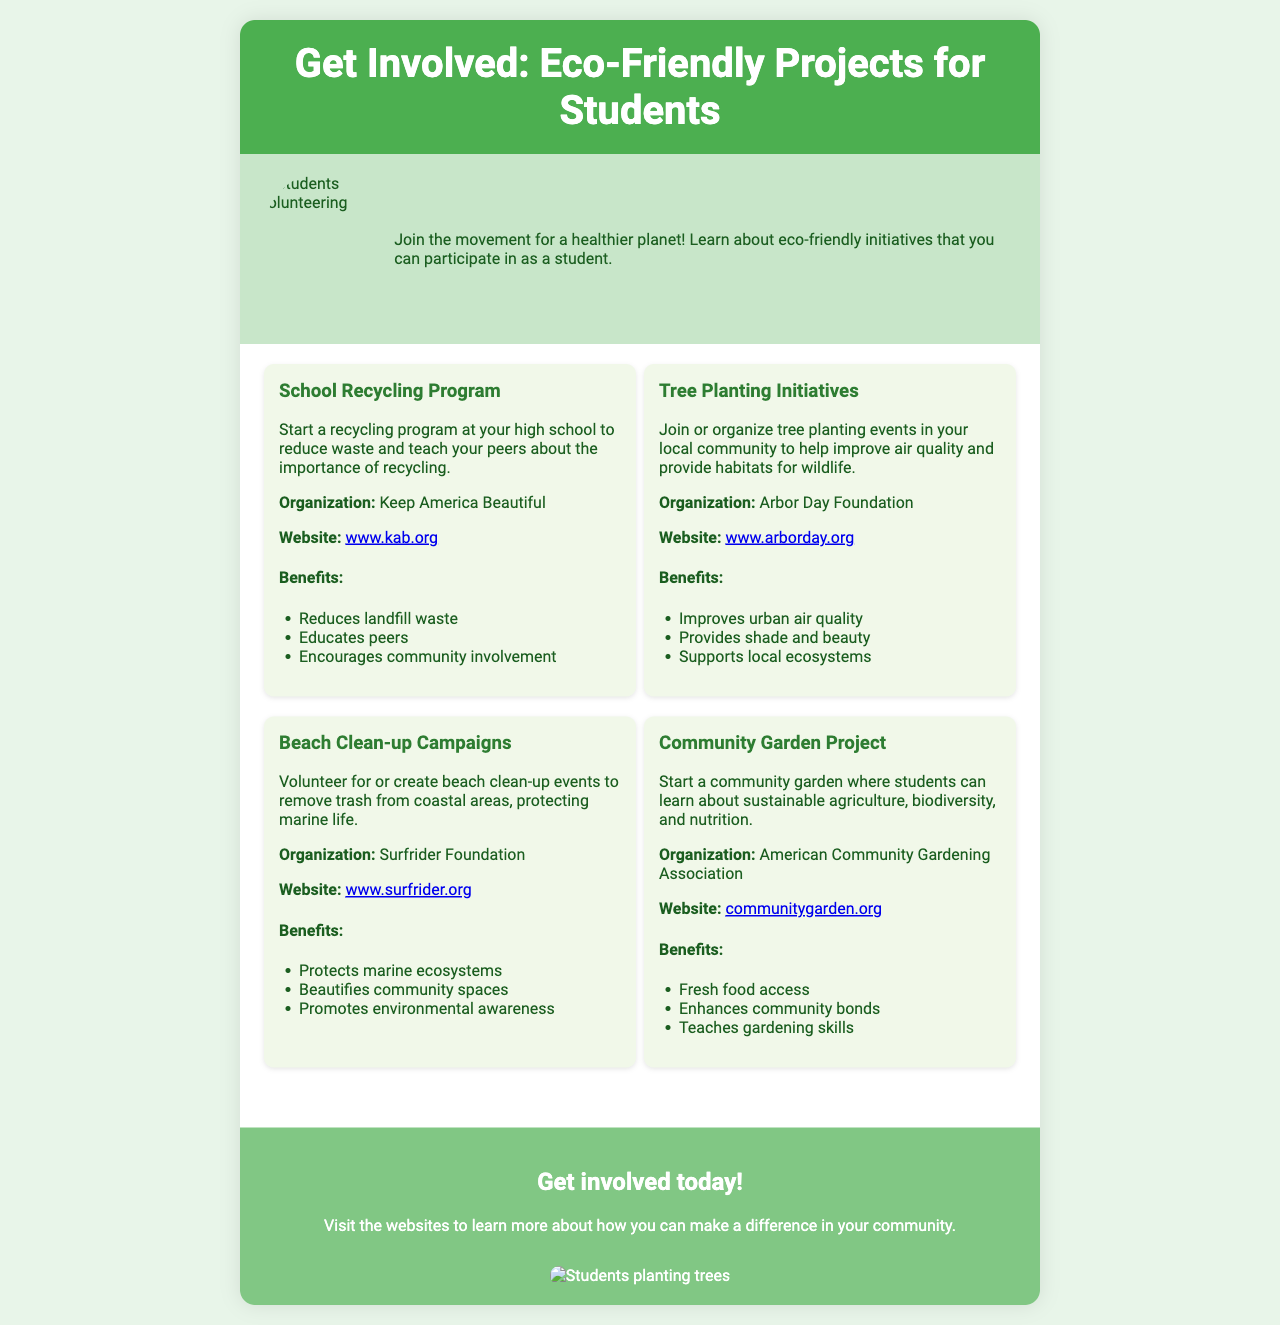What is the title of the brochure? The title is displayed prominently at the top of the document, providing insight into its purpose.
Answer: Get Involved: Eco-Friendly Projects for Students Who organizes the School Recycling Program? The organization responsible for this initiative is mentioned directly under the project description.
Answer: Keep America Beautiful What is one benefit of the Tree Planting Initiatives? The benefits are listed under each project, specifically targeting the positive impacts of participating.
Answer: Improves urban air quality How many eco-friendly projects are listed in the brochure? The document explicitly states the number of projects that students can get involved in.
Answer: Four What action does the call-to-action section encourage? The call-to-action section presents a clear directive for readers regarding their involvement.
Answer: Get involved today! What website can students visit for more information about community gardening? Each project includes a website for further exploration, highlighted after the organization name.
Answer: communitygarden.org What type of project is the Beach Clean-up Campaign? The project type is indicated in its title, summarizing its focus area effectively.
Answer: Clean-up Why is it important to involve students in these eco-friendly initiatives? The reasoning behind encouraging student involvement can be inferred from the overall goal of the brochure and its benefits sections.
Answer: Raise environmental awareness 